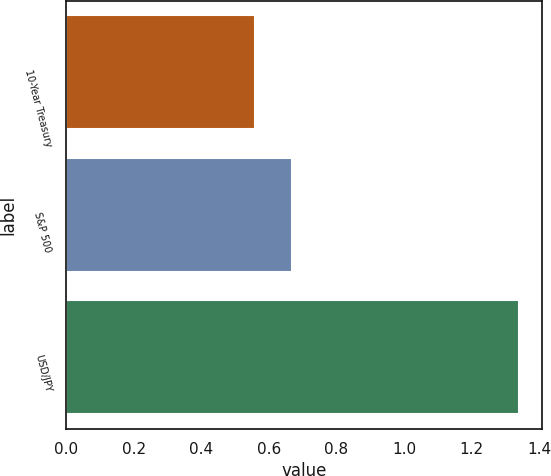Convert chart to OTSL. <chart><loc_0><loc_0><loc_500><loc_500><bar_chart><fcel>10-Year Treasury<fcel>S&P 500<fcel>USD/JPY<nl><fcel>0.56<fcel>0.67<fcel>1.34<nl></chart> 